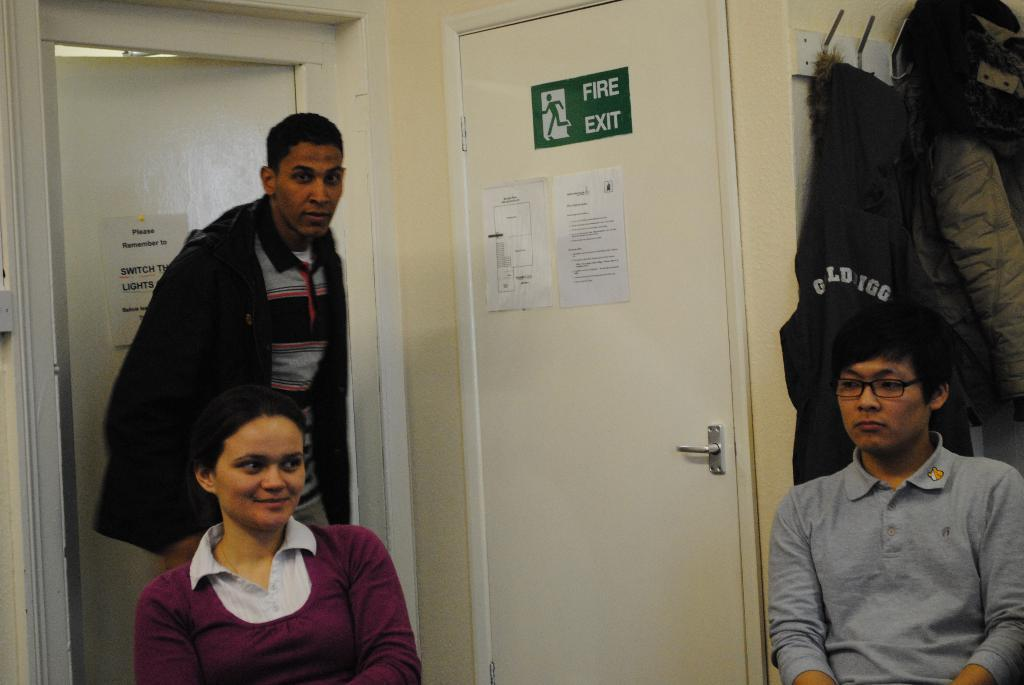How many people are in the room in the image? There are three persons in the room. What can be seen in the background of the image? There are two doors in the background. Where are the coats located in the image? The coats are hanged on the right side. What is attached to the doors in the image? Papers are visible on the door. Can you hear the argument between the persons in the image? There is no argument present in the image, and therefore no such sound can be heard. 